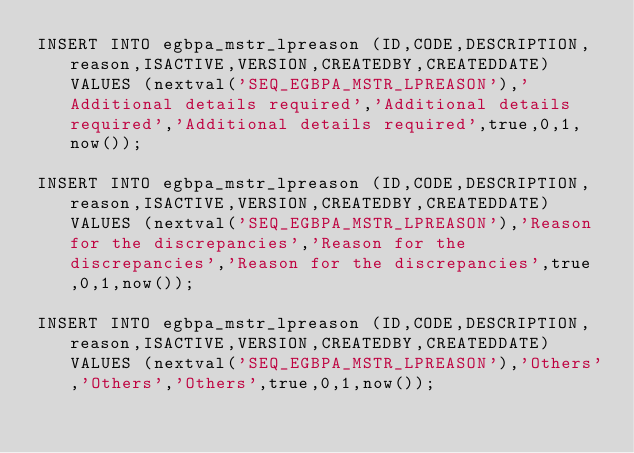Convert code to text. <code><loc_0><loc_0><loc_500><loc_500><_SQL_>INSERT INTO egbpa_mstr_lpreason (ID,CODE,DESCRIPTION,reason,ISACTIVE,VERSION,CREATEDBY,CREATEDDATE) VALUES (nextval('SEQ_EGBPA_MSTR_LPREASON'),'Additional details required','Additional details required','Additional details required',true,0,1,now());

INSERT INTO egbpa_mstr_lpreason (ID,CODE,DESCRIPTION,reason,ISACTIVE,VERSION,CREATEDBY,CREATEDDATE) VALUES (nextval('SEQ_EGBPA_MSTR_LPREASON'),'Reason for the discrepancies','Reason for the discrepancies','Reason for the discrepancies',true,0,1,now());

INSERT INTO egbpa_mstr_lpreason (ID,CODE,DESCRIPTION,reason,ISACTIVE,VERSION,CREATEDBY,CREATEDDATE) VALUES (nextval('SEQ_EGBPA_MSTR_LPREASON'),'Others','Others','Others',true,0,1,now());</code> 